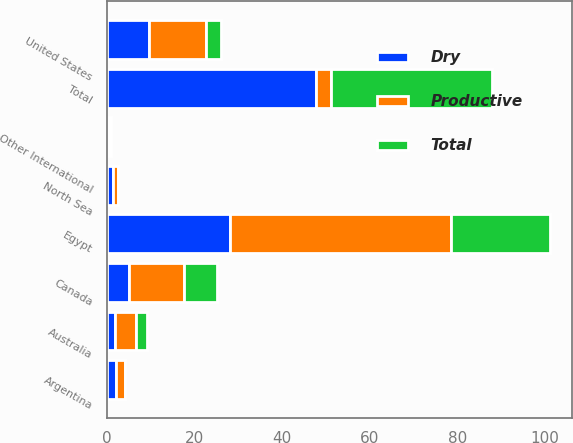Convert chart to OTSL. <chart><loc_0><loc_0><loc_500><loc_500><stacked_bar_chart><ecel><fcel>United States<fcel>Canada<fcel>Egypt<fcel>Australia<fcel>North Sea<fcel>Argentina<fcel>Other International<fcel>Total<nl><fcel>Dry<fcel>9.5<fcel>5<fcel>28<fcel>1.9<fcel>1.3<fcel>2<fcel>0<fcel>47.7<nl><fcel>Total<fcel>3.5<fcel>7.5<fcel>22.5<fcel>2.7<fcel>0<fcel>0<fcel>0.5<fcel>36.7<nl><fcel>Productive<fcel>13<fcel>12.5<fcel>50.5<fcel>4.6<fcel>1.3<fcel>2<fcel>0.5<fcel>3.5<nl></chart> 